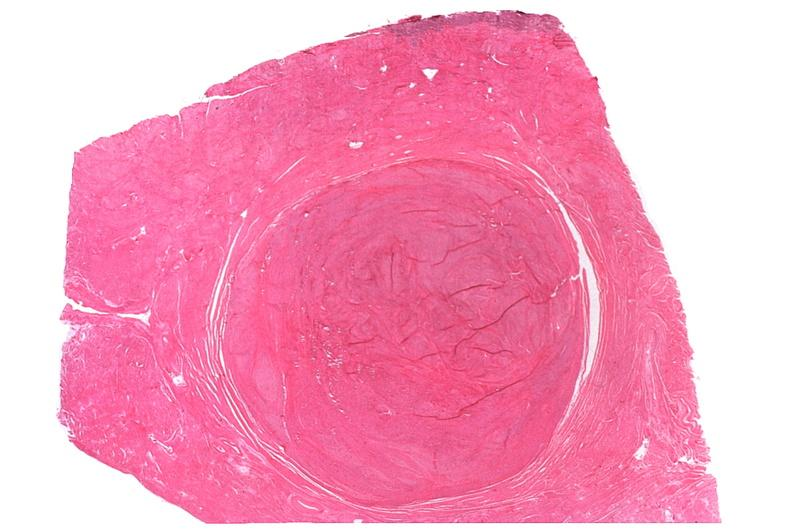does this image show uterus, leiomyomas?
Answer the question using a single word or phrase. Yes 